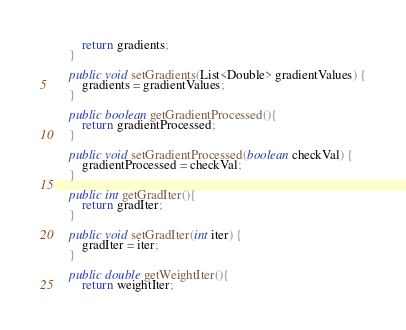Convert code to text. <code><loc_0><loc_0><loc_500><loc_500><_Java_>        return gradients;
    }

    public void setGradients(List<Double> gradientValues) {
        gradients = gradientValues;
    }

    public boolean getGradientProcessed(){
        return gradientProcessed;
    }

    public void setGradientProcessed(boolean checkVal) {
        gradientProcessed = checkVal;
    }

    public int getGradIter(){
        return gradIter;
    }

    public void setGradIter(int iter) {
        gradIter = iter;
    }

    public double getWeightIter(){
        return weightIter;</code> 